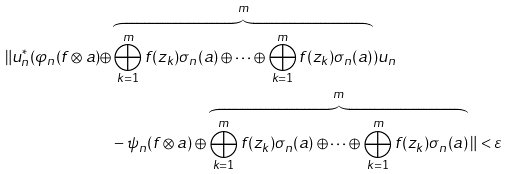<formula> <loc_0><loc_0><loc_500><loc_500>\| u _ { n } ^ { * } ( \varphi _ { n } ( f \otimes a ) \oplus & \overbrace { \bigoplus _ { k = 1 } ^ { m } f ( z _ { k } ) \sigma _ { n } ( a ) \oplus \cdots \oplus \bigoplus _ { k = 1 } ^ { m } f ( z _ { k } ) \sigma _ { n } ( a ) } ^ { m } ) u _ { n } \\ & - \psi _ { n } ( f \otimes a ) \oplus \overbrace { \bigoplus _ { k = 1 } ^ { m } f ( z _ { k } ) \sigma _ { n } ( a ) \oplus \cdots \oplus \bigoplus _ { k = 1 } ^ { m } f ( z _ { k } ) \sigma _ { n } ( a ) } ^ { m } \| < \varepsilon</formula> 